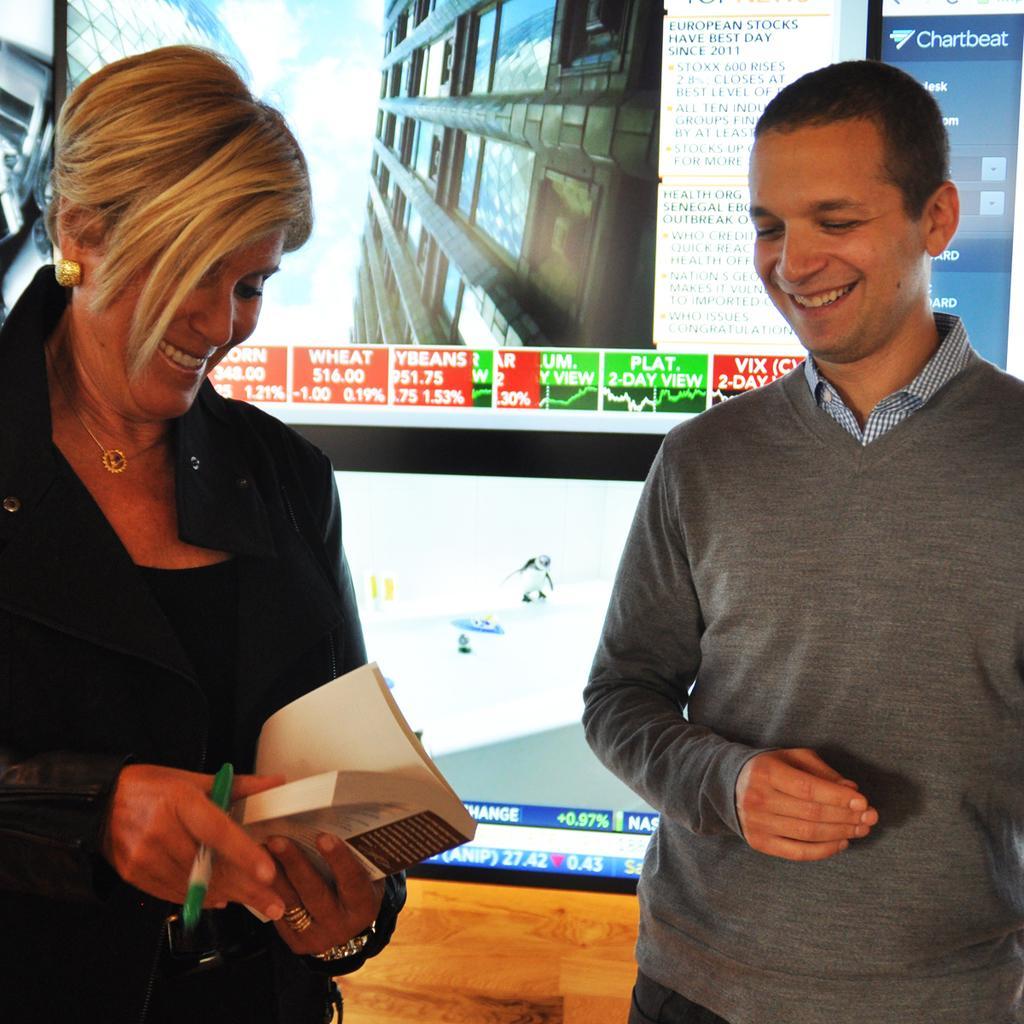Describe this image in one or two sentences. In this image I can see a woman wearing black color dress is standing and holding a pen and a book in her hand. I can see another person wearing grey colored dress is standing and smiling. In the background I can see the brown colored surface and few television screens. 